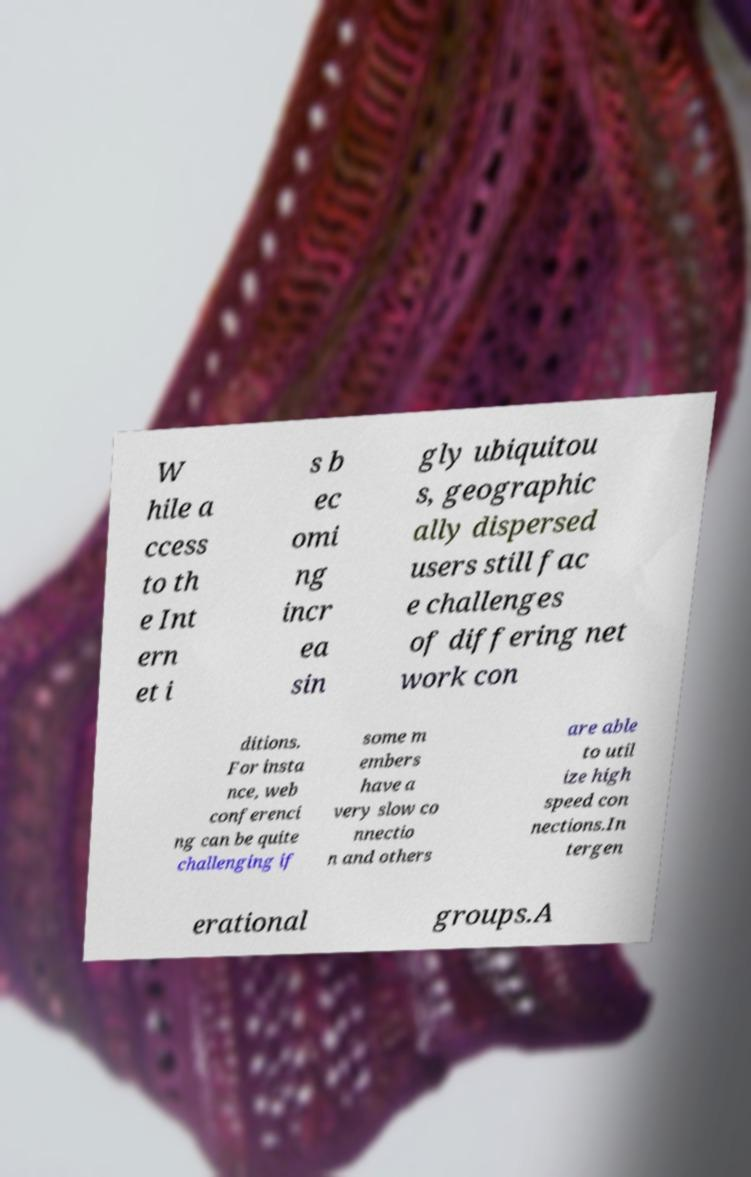Can you accurately transcribe the text from the provided image for me? W hile a ccess to th e Int ern et i s b ec omi ng incr ea sin gly ubiquitou s, geographic ally dispersed users still fac e challenges of differing net work con ditions. For insta nce, web conferenci ng can be quite challenging if some m embers have a very slow co nnectio n and others are able to util ize high speed con nections.In tergen erational groups.A 